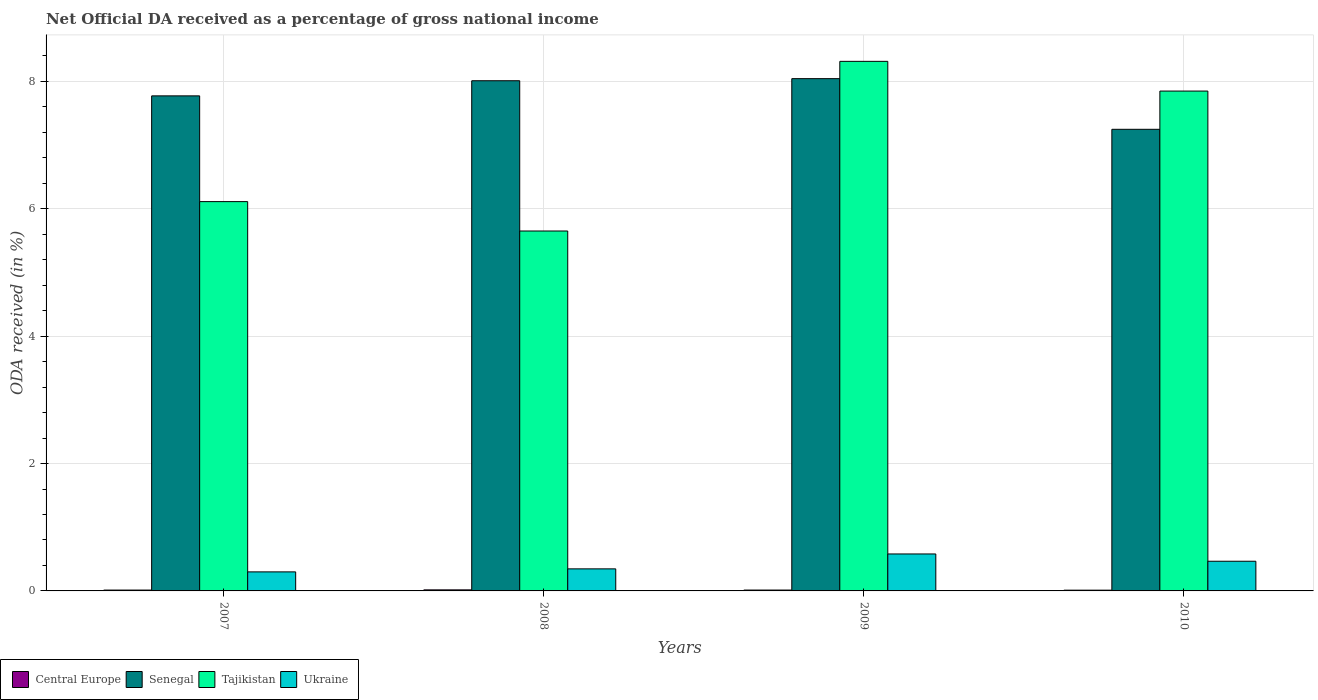How many different coloured bars are there?
Your answer should be very brief. 4. How many groups of bars are there?
Give a very brief answer. 4. Are the number of bars per tick equal to the number of legend labels?
Give a very brief answer. Yes. Are the number of bars on each tick of the X-axis equal?
Offer a very short reply. Yes. How many bars are there on the 4th tick from the right?
Keep it short and to the point. 4. What is the label of the 3rd group of bars from the left?
Ensure brevity in your answer.  2009. What is the net official DA received in Senegal in 2009?
Provide a succinct answer. 8.04. Across all years, what is the maximum net official DA received in Central Europe?
Provide a succinct answer. 0.02. Across all years, what is the minimum net official DA received in Tajikistan?
Offer a terse response. 5.65. In which year was the net official DA received in Central Europe maximum?
Provide a short and direct response. 2008. What is the total net official DA received in Central Europe in the graph?
Ensure brevity in your answer.  0.06. What is the difference between the net official DA received in Ukraine in 2008 and that in 2009?
Make the answer very short. -0.23. What is the difference between the net official DA received in Tajikistan in 2007 and the net official DA received in Ukraine in 2010?
Provide a succinct answer. 5.65. What is the average net official DA received in Ukraine per year?
Your answer should be very brief. 0.42. In the year 2009, what is the difference between the net official DA received in Tajikistan and net official DA received in Senegal?
Provide a short and direct response. 0.27. In how many years, is the net official DA received in Tajikistan greater than 7.2 %?
Your answer should be very brief. 2. What is the ratio of the net official DA received in Senegal in 2007 to that in 2009?
Provide a short and direct response. 0.97. What is the difference between the highest and the second highest net official DA received in Central Europe?
Make the answer very short. 0. What is the difference between the highest and the lowest net official DA received in Ukraine?
Provide a succinct answer. 0.28. What does the 1st bar from the left in 2007 represents?
Offer a very short reply. Central Europe. What does the 2nd bar from the right in 2008 represents?
Your answer should be compact. Tajikistan. Are all the bars in the graph horizontal?
Your answer should be very brief. No. Are the values on the major ticks of Y-axis written in scientific E-notation?
Keep it short and to the point. No. Does the graph contain grids?
Offer a terse response. Yes. How many legend labels are there?
Offer a very short reply. 4. How are the legend labels stacked?
Keep it short and to the point. Horizontal. What is the title of the graph?
Your answer should be very brief. Net Official DA received as a percentage of gross national income. What is the label or title of the Y-axis?
Your answer should be compact. ODA received (in %). What is the ODA received (in %) in Central Europe in 2007?
Provide a short and direct response. 0.01. What is the ODA received (in %) in Senegal in 2007?
Provide a succinct answer. 7.77. What is the ODA received (in %) in Tajikistan in 2007?
Provide a short and direct response. 6.11. What is the ODA received (in %) in Ukraine in 2007?
Ensure brevity in your answer.  0.3. What is the ODA received (in %) in Central Europe in 2008?
Offer a terse response. 0.02. What is the ODA received (in %) in Senegal in 2008?
Keep it short and to the point. 8.01. What is the ODA received (in %) of Tajikistan in 2008?
Give a very brief answer. 5.65. What is the ODA received (in %) of Ukraine in 2008?
Offer a terse response. 0.35. What is the ODA received (in %) in Central Europe in 2009?
Give a very brief answer. 0.01. What is the ODA received (in %) in Senegal in 2009?
Your response must be concise. 8.04. What is the ODA received (in %) in Tajikistan in 2009?
Provide a short and direct response. 8.32. What is the ODA received (in %) in Ukraine in 2009?
Provide a succinct answer. 0.58. What is the ODA received (in %) of Central Europe in 2010?
Make the answer very short. 0.01. What is the ODA received (in %) of Senegal in 2010?
Your answer should be compact. 7.25. What is the ODA received (in %) in Tajikistan in 2010?
Your answer should be compact. 7.85. What is the ODA received (in %) in Ukraine in 2010?
Your response must be concise. 0.47. Across all years, what is the maximum ODA received (in %) in Central Europe?
Your response must be concise. 0.02. Across all years, what is the maximum ODA received (in %) in Senegal?
Your answer should be very brief. 8.04. Across all years, what is the maximum ODA received (in %) in Tajikistan?
Offer a terse response. 8.32. Across all years, what is the maximum ODA received (in %) of Ukraine?
Offer a very short reply. 0.58. Across all years, what is the minimum ODA received (in %) in Central Europe?
Provide a short and direct response. 0.01. Across all years, what is the minimum ODA received (in %) in Senegal?
Give a very brief answer. 7.25. Across all years, what is the minimum ODA received (in %) of Tajikistan?
Provide a succinct answer. 5.65. Across all years, what is the minimum ODA received (in %) in Ukraine?
Make the answer very short. 0.3. What is the total ODA received (in %) of Central Europe in the graph?
Provide a short and direct response. 0.06. What is the total ODA received (in %) of Senegal in the graph?
Offer a very short reply. 31.08. What is the total ODA received (in %) of Tajikistan in the graph?
Keep it short and to the point. 27.93. What is the total ODA received (in %) of Ukraine in the graph?
Your answer should be compact. 1.69. What is the difference between the ODA received (in %) of Central Europe in 2007 and that in 2008?
Offer a terse response. -0. What is the difference between the ODA received (in %) of Senegal in 2007 and that in 2008?
Make the answer very short. -0.24. What is the difference between the ODA received (in %) of Tajikistan in 2007 and that in 2008?
Keep it short and to the point. 0.46. What is the difference between the ODA received (in %) of Ukraine in 2007 and that in 2008?
Give a very brief answer. -0.05. What is the difference between the ODA received (in %) in Central Europe in 2007 and that in 2009?
Offer a terse response. -0. What is the difference between the ODA received (in %) in Senegal in 2007 and that in 2009?
Your answer should be compact. -0.27. What is the difference between the ODA received (in %) of Tajikistan in 2007 and that in 2009?
Keep it short and to the point. -2.2. What is the difference between the ODA received (in %) in Ukraine in 2007 and that in 2009?
Provide a short and direct response. -0.28. What is the difference between the ODA received (in %) in Central Europe in 2007 and that in 2010?
Your response must be concise. 0. What is the difference between the ODA received (in %) of Senegal in 2007 and that in 2010?
Your response must be concise. 0.53. What is the difference between the ODA received (in %) in Tajikistan in 2007 and that in 2010?
Give a very brief answer. -1.74. What is the difference between the ODA received (in %) of Ukraine in 2007 and that in 2010?
Provide a succinct answer. -0.17. What is the difference between the ODA received (in %) in Central Europe in 2008 and that in 2009?
Your answer should be very brief. 0. What is the difference between the ODA received (in %) of Senegal in 2008 and that in 2009?
Ensure brevity in your answer.  -0.03. What is the difference between the ODA received (in %) of Tajikistan in 2008 and that in 2009?
Your answer should be compact. -2.66. What is the difference between the ODA received (in %) of Ukraine in 2008 and that in 2009?
Keep it short and to the point. -0.23. What is the difference between the ODA received (in %) of Central Europe in 2008 and that in 2010?
Keep it short and to the point. 0. What is the difference between the ODA received (in %) in Senegal in 2008 and that in 2010?
Provide a short and direct response. 0.76. What is the difference between the ODA received (in %) of Tajikistan in 2008 and that in 2010?
Provide a short and direct response. -2.2. What is the difference between the ODA received (in %) of Ukraine in 2008 and that in 2010?
Give a very brief answer. -0.12. What is the difference between the ODA received (in %) of Central Europe in 2009 and that in 2010?
Provide a succinct answer. 0. What is the difference between the ODA received (in %) of Senegal in 2009 and that in 2010?
Your answer should be very brief. 0.8. What is the difference between the ODA received (in %) of Tajikistan in 2009 and that in 2010?
Your response must be concise. 0.47. What is the difference between the ODA received (in %) in Ukraine in 2009 and that in 2010?
Provide a succinct answer. 0.11. What is the difference between the ODA received (in %) in Central Europe in 2007 and the ODA received (in %) in Senegal in 2008?
Your answer should be very brief. -8. What is the difference between the ODA received (in %) in Central Europe in 2007 and the ODA received (in %) in Tajikistan in 2008?
Your answer should be compact. -5.64. What is the difference between the ODA received (in %) in Central Europe in 2007 and the ODA received (in %) in Ukraine in 2008?
Your answer should be very brief. -0.33. What is the difference between the ODA received (in %) of Senegal in 2007 and the ODA received (in %) of Tajikistan in 2008?
Offer a very short reply. 2.12. What is the difference between the ODA received (in %) in Senegal in 2007 and the ODA received (in %) in Ukraine in 2008?
Keep it short and to the point. 7.43. What is the difference between the ODA received (in %) of Tajikistan in 2007 and the ODA received (in %) of Ukraine in 2008?
Give a very brief answer. 5.77. What is the difference between the ODA received (in %) of Central Europe in 2007 and the ODA received (in %) of Senegal in 2009?
Provide a succinct answer. -8.03. What is the difference between the ODA received (in %) in Central Europe in 2007 and the ODA received (in %) in Tajikistan in 2009?
Your answer should be compact. -8.3. What is the difference between the ODA received (in %) in Central Europe in 2007 and the ODA received (in %) in Ukraine in 2009?
Provide a short and direct response. -0.57. What is the difference between the ODA received (in %) of Senegal in 2007 and the ODA received (in %) of Tajikistan in 2009?
Make the answer very short. -0.54. What is the difference between the ODA received (in %) of Senegal in 2007 and the ODA received (in %) of Ukraine in 2009?
Make the answer very short. 7.19. What is the difference between the ODA received (in %) in Tajikistan in 2007 and the ODA received (in %) in Ukraine in 2009?
Offer a terse response. 5.53. What is the difference between the ODA received (in %) of Central Europe in 2007 and the ODA received (in %) of Senegal in 2010?
Give a very brief answer. -7.23. What is the difference between the ODA received (in %) in Central Europe in 2007 and the ODA received (in %) in Tajikistan in 2010?
Provide a short and direct response. -7.83. What is the difference between the ODA received (in %) in Central Europe in 2007 and the ODA received (in %) in Ukraine in 2010?
Make the answer very short. -0.45. What is the difference between the ODA received (in %) in Senegal in 2007 and the ODA received (in %) in Tajikistan in 2010?
Ensure brevity in your answer.  -0.08. What is the difference between the ODA received (in %) of Senegal in 2007 and the ODA received (in %) of Ukraine in 2010?
Your answer should be compact. 7.31. What is the difference between the ODA received (in %) in Tajikistan in 2007 and the ODA received (in %) in Ukraine in 2010?
Your response must be concise. 5.65. What is the difference between the ODA received (in %) of Central Europe in 2008 and the ODA received (in %) of Senegal in 2009?
Offer a terse response. -8.03. What is the difference between the ODA received (in %) of Central Europe in 2008 and the ODA received (in %) of Tajikistan in 2009?
Offer a terse response. -8.3. What is the difference between the ODA received (in %) in Central Europe in 2008 and the ODA received (in %) in Ukraine in 2009?
Keep it short and to the point. -0.56. What is the difference between the ODA received (in %) in Senegal in 2008 and the ODA received (in %) in Tajikistan in 2009?
Provide a succinct answer. -0.3. What is the difference between the ODA received (in %) of Senegal in 2008 and the ODA received (in %) of Ukraine in 2009?
Offer a very short reply. 7.43. What is the difference between the ODA received (in %) in Tajikistan in 2008 and the ODA received (in %) in Ukraine in 2009?
Offer a very short reply. 5.07. What is the difference between the ODA received (in %) of Central Europe in 2008 and the ODA received (in %) of Senegal in 2010?
Keep it short and to the point. -7.23. What is the difference between the ODA received (in %) in Central Europe in 2008 and the ODA received (in %) in Tajikistan in 2010?
Provide a short and direct response. -7.83. What is the difference between the ODA received (in %) in Central Europe in 2008 and the ODA received (in %) in Ukraine in 2010?
Your answer should be very brief. -0.45. What is the difference between the ODA received (in %) of Senegal in 2008 and the ODA received (in %) of Tajikistan in 2010?
Keep it short and to the point. 0.16. What is the difference between the ODA received (in %) in Senegal in 2008 and the ODA received (in %) in Ukraine in 2010?
Ensure brevity in your answer.  7.54. What is the difference between the ODA received (in %) in Tajikistan in 2008 and the ODA received (in %) in Ukraine in 2010?
Provide a short and direct response. 5.19. What is the difference between the ODA received (in %) in Central Europe in 2009 and the ODA received (in %) in Senegal in 2010?
Provide a short and direct response. -7.23. What is the difference between the ODA received (in %) in Central Europe in 2009 and the ODA received (in %) in Tajikistan in 2010?
Give a very brief answer. -7.83. What is the difference between the ODA received (in %) of Central Europe in 2009 and the ODA received (in %) of Ukraine in 2010?
Offer a very short reply. -0.45. What is the difference between the ODA received (in %) in Senegal in 2009 and the ODA received (in %) in Tajikistan in 2010?
Offer a very short reply. 0.19. What is the difference between the ODA received (in %) of Senegal in 2009 and the ODA received (in %) of Ukraine in 2010?
Provide a short and direct response. 7.58. What is the difference between the ODA received (in %) of Tajikistan in 2009 and the ODA received (in %) of Ukraine in 2010?
Make the answer very short. 7.85. What is the average ODA received (in %) of Central Europe per year?
Your response must be concise. 0.01. What is the average ODA received (in %) in Senegal per year?
Keep it short and to the point. 7.77. What is the average ODA received (in %) in Tajikistan per year?
Provide a succinct answer. 6.98. What is the average ODA received (in %) in Ukraine per year?
Provide a succinct answer. 0.42. In the year 2007, what is the difference between the ODA received (in %) in Central Europe and ODA received (in %) in Senegal?
Make the answer very short. -7.76. In the year 2007, what is the difference between the ODA received (in %) in Central Europe and ODA received (in %) in Tajikistan?
Provide a short and direct response. -6.1. In the year 2007, what is the difference between the ODA received (in %) of Central Europe and ODA received (in %) of Ukraine?
Keep it short and to the point. -0.29. In the year 2007, what is the difference between the ODA received (in %) of Senegal and ODA received (in %) of Tajikistan?
Ensure brevity in your answer.  1.66. In the year 2007, what is the difference between the ODA received (in %) in Senegal and ODA received (in %) in Ukraine?
Your answer should be compact. 7.47. In the year 2007, what is the difference between the ODA received (in %) of Tajikistan and ODA received (in %) of Ukraine?
Provide a succinct answer. 5.81. In the year 2008, what is the difference between the ODA received (in %) in Central Europe and ODA received (in %) in Senegal?
Your answer should be very brief. -7.99. In the year 2008, what is the difference between the ODA received (in %) of Central Europe and ODA received (in %) of Tajikistan?
Provide a short and direct response. -5.63. In the year 2008, what is the difference between the ODA received (in %) of Central Europe and ODA received (in %) of Ukraine?
Your response must be concise. -0.33. In the year 2008, what is the difference between the ODA received (in %) of Senegal and ODA received (in %) of Tajikistan?
Offer a very short reply. 2.36. In the year 2008, what is the difference between the ODA received (in %) of Senegal and ODA received (in %) of Ukraine?
Your response must be concise. 7.66. In the year 2008, what is the difference between the ODA received (in %) of Tajikistan and ODA received (in %) of Ukraine?
Provide a short and direct response. 5.3. In the year 2009, what is the difference between the ODA received (in %) in Central Europe and ODA received (in %) in Senegal?
Give a very brief answer. -8.03. In the year 2009, what is the difference between the ODA received (in %) in Central Europe and ODA received (in %) in Tajikistan?
Give a very brief answer. -8.3. In the year 2009, what is the difference between the ODA received (in %) in Central Europe and ODA received (in %) in Ukraine?
Keep it short and to the point. -0.57. In the year 2009, what is the difference between the ODA received (in %) in Senegal and ODA received (in %) in Tajikistan?
Your answer should be very brief. -0.27. In the year 2009, what is the difference between the ODA received (in %) of Senegal and ODA received (in %) of Ukraine?
Offer a very short reply. 7.46. In the year 2009, what is the difference between the ODA received (in %) in Tajikistan and ODA received (in %) in Ukraine?
Your answer should be very brief. 7.73. In the year 2010, what is the difference between the ODA received (in %) in Central Europe and ODA received (in %) in Senegal?
Ensure brevity in your answer.  -7.24. In the year 2010, what is the difference between the ODA received (in %) in Central Europe and ODA received (in %) in Tajikistan?
Offer a terse response. -7.84. In the year 2010, what is the difference between the ODA received (in %) in Central Europe and ODA received (in %) in Ukraine?
Offer a very short reply. -0.45. In the year 2010, what is the difference between the ODA received (in %) in Senegal and ODA received (in %) in Tajikistan?
Your response must be concise. -0.6. In the year 2010, what is the difference between the ODA received (in %) in Senegal and ODA received (in %) in Ukraine?
Offer a terse response. 6.78. In the year 2010, what is the difference between the ODA received (in %) in Tajikistan and ODA received (in %) in Ukraine?
Your answer should be compact. 7.38. What is the ratio of the ODA received (in %) of Central Europe in 2007 to that in 2008?
Make the answer very short. 0.82. What is the ratio of the ODA received (in %) in Senegal in 2007 to that in 2008?
Give a very brief answer. 0.97. What is the ratio of the ODA received (in %) in Tajikistan in 2007 to that in 2008?
Your answer should be compact. 1.08. What is the ratio of the ODA received (in %) in Ukraine in 2007 to that in 2008?
Offer a terse response. 0.86. What is the ratio of the ODA received (in %) of Central Europe in 2007 to that in 2009?
Your answer should be very brief. 0.99. What is the ratio of the ODA received (in %) in Senegal in 2007 to that in 2009?
Your answer should be compact. 0.97. What is the ratio of the ODA received (in %) of Tajikistan in 2007 to that in 2009?
Keep it short and to the point. 0.74. What is the ratio of the ODA received (in %) in Ukraine in 2007 to that in 2009?
Offer a very short reply. 0.52. What is the ratio of the ODA received (in %) in Central Europe in 2007 to that in 2010?
Your response must be concise. 1.13. What is the ratio of the ODA received (in %) of Senegal in 2007 to that in 2010?
Your answer should be compact. 1.07. What is the ratio of the ODA received (in %) of Tajikistan in 2007 to that in 2010?
Offer a very short reply. 0.78. What is the ratio of the ODA received (in %) in Ukraine in 2007 to that in 2010?
Ensure brevity in your answer.  0.64. What is the ratio of the ODA received (in %) of Central Europe in 2008 to that in 2009?
Offer a very short reply. 1.21. What is the ratio of the ODA received (in %) in Tajikistan in 2008 to that in 2009?
Make the answer very short. 0.68. What is the ratio of the ODA received (in %) in Ukraine in 2008 to that in 2009?
Your answer should be compact. 0.6. What is the ratio of the ODA received (in %) of Central Europe in 2008 to that in 2010?
Your answer should be very brief. 1.38. What is the ratio of the ODA received (in %) of Senegal in 2008 to that in 2010?
Offer a terse response. 1.11. What is the ratio of the ODA received (in %) in Tajikistan in 2008 to that in 2010?
Keep it short and to the point. 0.72. What is the ratio of the ODA received (in %) in Ukraine in 2008 to that in 2010?
Ensure brevity in your answer.  0.74. What is the ratio of the ODA received (in %) of Central Europe in 2009 to that in 2010?
Provide a succinct answer. 1.15. What is the ratio of the ODA received (in %) in Senegal in 2009 to that in 2010?
Provide a short and direct response. 1.11. What is the ratio of the ODA received (in %) of Tajikistan in 2009 to that in 2010?
Offer a very short reply. 1.06. What is the ratio of the ODA received (in %) of Ukraine in 2009 to that in 2010?
Your answer should be compact. 1.25. What is the difference between the highest and the second highest ODA received (in %) in Central Europe?
Ensure brevity in your answer.  0. What is the difference between the highest and the second highest ODA received (in %) of Senegal?
Give a very brief answer. 0.03. What is the difference between the highest and the second highest ODA received (in %) in Tajikistan?
Keep it short and to the point. 0.47. What is the difference between the highest and the second highest ODA received (in %) in Ukraine?
Make the answer very short. 0.11. What is the difference between the highest and the lowest ODA received (in %) of Central Europe?
Offer a very short reply. 0. What is the difference between the highest and the lowest ODA received (in %) of Senegal?
Your answer should be very brief. 0.8. What is the difference between the highest and the lowest ODA received (in %) in Tajikistan?
Make the answer very short. 2.66. What is the difference between the highest and the lowest ODA received (in %) of Ukraine?
Ensure brevity in your answer.  0.28. 